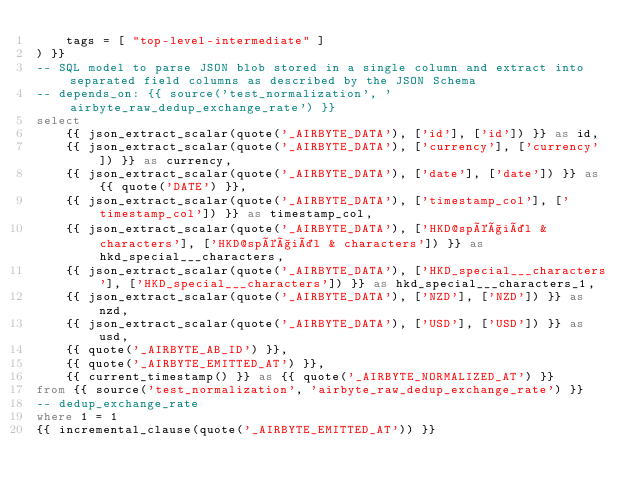<code> <loc_0><loc_0><loc_500><loc_500><_SQL_>    tags = [ "top-level-intermediate" ]
) }}
-- SQL model to parse JSON blob stored in a single column and extract into separated field columns as described by the JSON Schema
-- depends_on: {{ source('test_normalization', 'airbyte_raw_dedup_exchange_rate') }}
select
    {{ json_extract_scalar(quote('_AIRBYTE_DATA'), ['id'], ['id']) }} as id,
    {{ json_extract_scalar(quote('_AIRBYTE_DATA'), ['currency'], ['currency']) }} as currency,
    {{ json_extract_scalar(quote('_AIRBYTE_DATA'), ['date'], ['date']) }} as {{ quote('DATE') }},
    {{ json_extract_scalar(quote('_AIRBYTE_DATA'), ['timestamp_col'], ['timestamp_col']) }} as timestamp_col,
    {{ json_extract_scalar(quote('_AIRBYTE_DATA'), ['HKD@spéçiäl & characters'], ['HKD@spéçiäl & characters']) }} as hkd_special___characters,
    {{ json_extract_scalar(quote('_AIRBYTE_DATA'), ['HKD_special___characters'], ['HKD_special___characters']) }} as hkd_special___characters_1,
    {{ json_extract_scalar(quote('_AIRBYTE_DATA'), ['NZD'], ['NZD']) }} as nzd,
    {{ json_extract_scalar(quote('_AIRBYTE_DATA'), ['USD'], ['USD']) }} as usd,
    {{ quote('_AIRBYTE_AB_ID') }},
    {{ quote('_AIRBYTE_EMITTED_AT') }},
    {{ current_timestamp() }} as {{ quote('_AIRBYTE_NORMALIZED_AT') }}
from {{ source('test_normalization', 'airbyte_raw_dedup_exchange_rate') }} 
-- dedup_exchange_rate
where 1 = 1
{{ incremental_clause(quote('_AIRBYTE_EMITTED_AT')) }}

</code> 